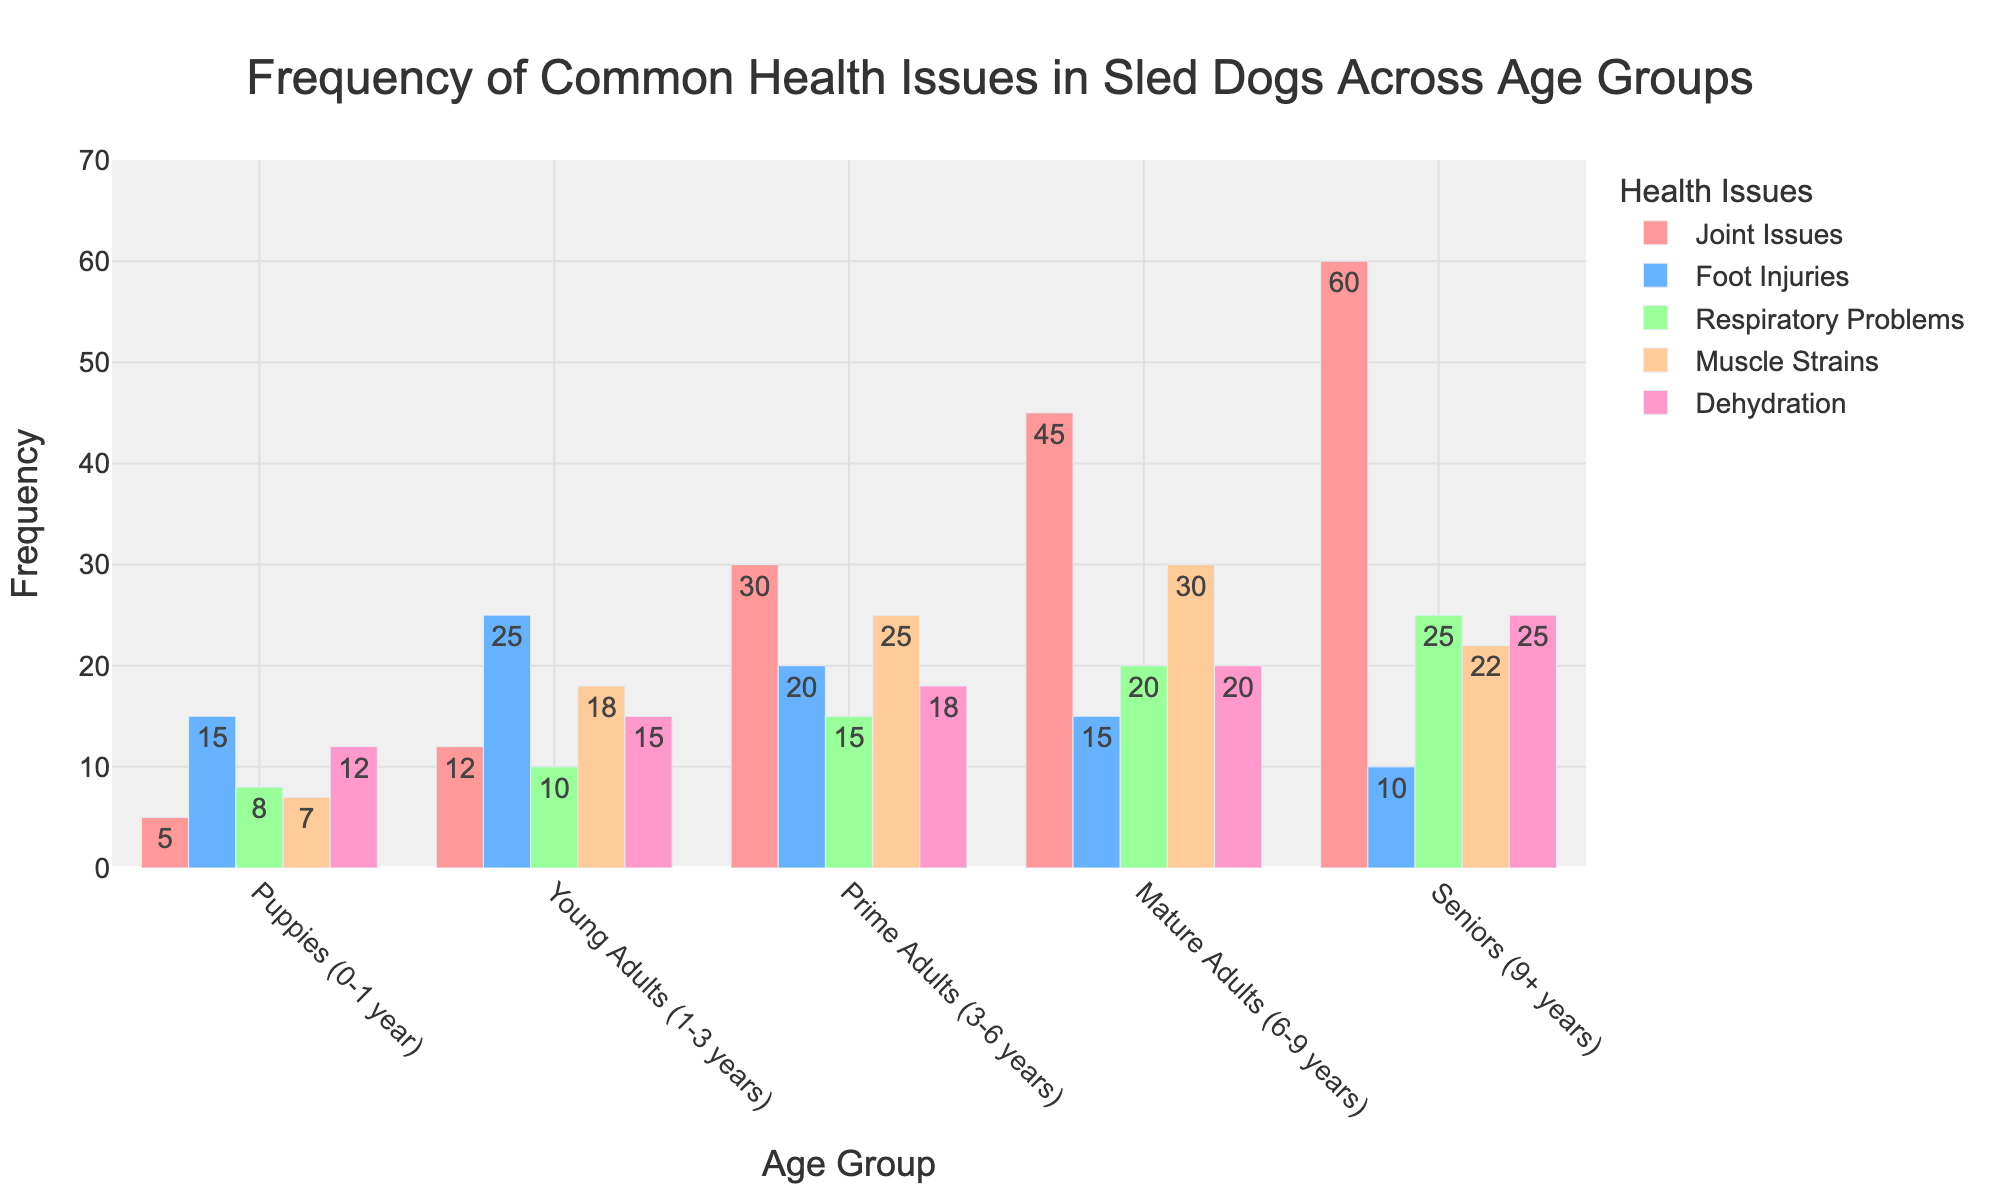**What's the most common health issue in Mature Adults (6-9 years)?** Look at the bars corresponding to the Mature Adults age group and identify the tallest bar. The tallest bar represents Joint Issues with a frequency of 45.
Answer: Joint Issues **Which age group experiences the highest frequency of Dehydration?** Look at the bars representing Dehydration across all age groups and find the tallest one. The tallest bar is found in the Seniors (9+ years) age group with a frequency of 25.
Answer: Seniors (9+ years) **Compare the frequency of Foot Injuries between Puppies (0-1 year) and Young Adults (1-3 years). Which group has more cases and by how much?** Find the bars for Foot Injuries in both Puppies and Young Adults. Puppies have a frequency of 15, and Young Adults have a frequency of 25. The difference is 25 - 15 = 10 cases.
Answer: Young Adults by 10 **What's the total number of Muscle Strains across all age groups?** Sum the frequencies of Muscle Strains for all age groups (7 + 18 + 25 + 30 + 22). The total is 7 + 18 + 25 + 30 + 22 = 102.
Answer: 102 **How does the frequency of Respiratory Problems in Prime Adults (3-6 years) compare to that in Young Adults (1-3 years)?** Look for the bars corresponding to Respiratory Problems in both age groups. Prime Adults have a frequency of 15, and Young Adults have a frequency of 10. Prime Adults have 5 more cases.
Answer: Prime Adults have 5 more cases **Which health issue has the least frequency in Seniors (9+ years) and what is its value?** Look for the shortest bar in the Seniors age group. The shortest bar represents Foot Injuries, with a frequency of 10.
Answer: Foot Injuries, 10 **If Joint Issues and Muscle Strains were combined into one category called 'Musculoskeletal Issues', what would be the total frequency for Prime Adults (3-6 years)?** Add the frequencies of Joint Issues and Muscle Strains for Prime Adults. Joint Issues have a frequency of 30, and Muscle Strains have a frequency of 25. Combined, the total is 30 + 25 = 55.
Answer: 55 **What’s the ratio of Muscle Strains in Puppies (0-1 year) to that in Mature Adults (6-9 years)?** Find the frequencies of Muscle Strains in Puppies and Mature Adults. Puppies have a frequency of 7, and Mature Adults have a frequency of 30. The ratio is 7:30, which simplifies to 7/30.
Answer: 7:30 or 7/30 **Which age group has the highest number of Respiratory Problems, and what is that number?** Look across all age groups for the tallest bar representing Respiratory Problems. It is in the Seniors (9+ years) age group, with a frequency of 25.
Answer: Seniors (9+ years), 25 